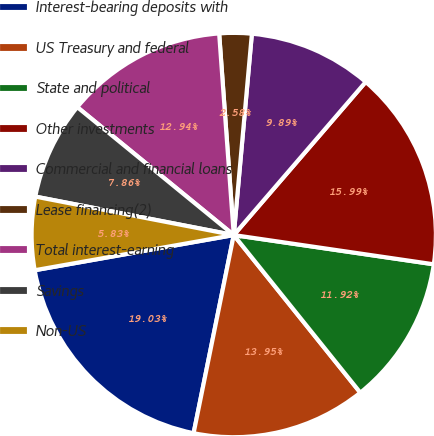Convert chart to OTSL. <chart><loc_0><loc_0><loc_500><loc_500><pie_chart><fcel>Interest-bearing deposits with<fcel>US Treasury and federal<fcel>State and political<fcel>Other investments<fcel>Commercial and financial loans<fcel>Lease financing(2)<fcel>Total interest-earning<fcel>Savings<fcel>Non-US<nl><fcel>19.03%<fcel>13.95%<fcel>11.92%<fcel>15.99%<fcel>9.89%<fcel>2.58%<fcel>12.94%<fcel>7.86%<fcel>5.83%<nl></chart> 